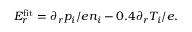Convert formula to latex. <formula><loc_0><loc_0><loc_500><loc_500>E _ { r } ^ { f i t } = \partial _ { r } p _ { i } / e n _ { i } - 0 . 4 \partial _ { r } T _ { i } / e .</formula> 